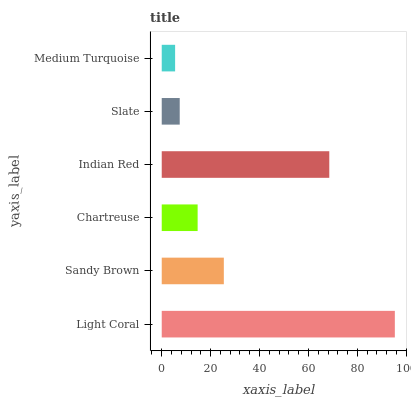Is Medium Turquoise the minimum?
Answer yes or no. Yes. Is Light Coral the maximum?
Answer yes or no. Yes. Is Sandy Brown the minimum?
Answer yes or no. No. Is Sandy Brown the maximum?
Answer yes or no. No. Is Light Coral greater than Sandy Brown?
Answer yes or no. Yes. Is Sandy Brown less than Light Coral?
Answer yes or no. Yes. Is Sandy Brown greater than Light Coral?
Answer yes or no. No. Is Light Coral less than Sandy Brown?
Answer yes or no. No. Is Sandy Brown the high median?
Answer yes or no. Yes. Is Chartreuse the low median?
Answer yes or no. Yes. Is Indian Red the high median?
Answer yes or no. No. Is Slate the low median?
Answer yes or no. No. 